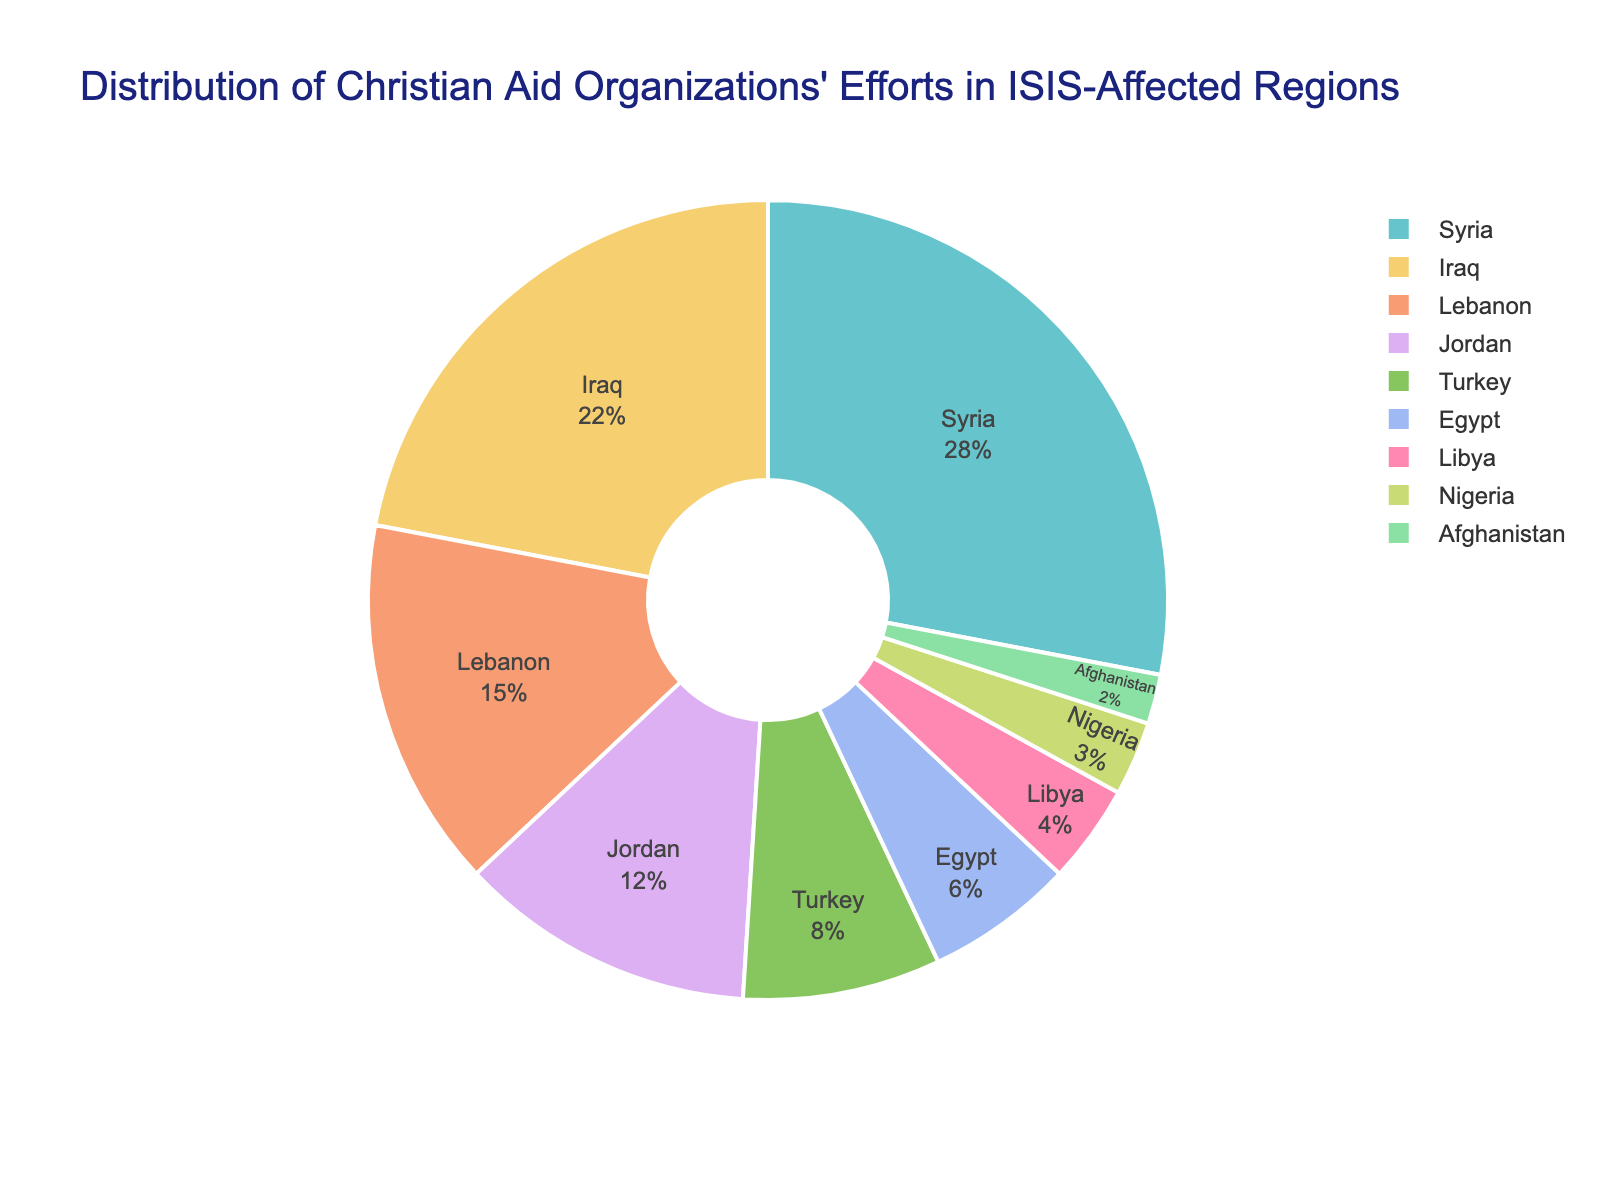Which region receives the highest percentage of aid? The pie chart shows the distribution of aid percentages among different regions. The region with the largest segment represents the highest percentage.
Answer: Syria What is the combined percentage of aid going to Syria and Iraq? From the pie chart, we see that Syria receives 28% and Iraq receives 22%. Summing these percentages gives 28 + 22 = 50%.
Answer: 50% Which regions receive less than 10% of aid each? The pie chart segments representing Turkey, Egypt, Libya, Nigeria, and Afghanistan show less than 10%.
Answer: Turkey, Egypt, Libya, Nigeria, Afghanistan How much more aid percentage does Syria receive compared to Lebanon? Syria receives 28% and Lebanon receives 15%. The difference is calculated as 28 - 15 = 13%.
Answer: 13% What is the average percentage of aid received by Jordan, Turkey, and Egypt? The percentages for Jordan, Turkey, and Egypt are 12%, 8%, and 6% respectively. Calculate the average as (12 + 8 + 6) / 3 = 26 / 3 ≈ 8.67%.
Answer: 8.67% Compare the percentage of aid given to Syria with the total percentage of aid given to Jordan, Turkey, and Egypt combined. Which is higher? Syria receives 28% of aid. Jordan, Turkey, and Egypt together receive 12% + 8% + 6% = 26%. Since 28% is greater than 26%, Syria receives a higher percentage compared to the combined aid received by Jordan, Turkey, and Egypt.
Answer: Syria What is the percentage difference between the regions with the highest and lowest aid? The highest aid percentage is for Syria at 28% and the lowest is for Afghanistan at 2%. The difference is 28 - 2 = 26%.
Answer: 26% If the aid percentage for Syria were to decrease by 10% and be equally redistributed among Iraq, Lebanon, and Jordan, what would be the new aid percentages for these regions? Syria's new percentage would be 28% - 10% = 18%. The 10% reduction will be equally redistributed. Each of Iraq, Lebanon, and Jordan gets an additional 10% / 3 ≈ 3.33%. Iraq's new percentage: 22% + 3.33% ≈ 25.33%; Lebanon's new percentage: 15% + 3.33% ≈ 18.33%; Jordan's new percentage: 12% + 3.33% ≈ 15.33%.
Answer: Syria: 18%, Iraq: 25.33%, Lebanon: 18.33%, Jordan: 15.33% 